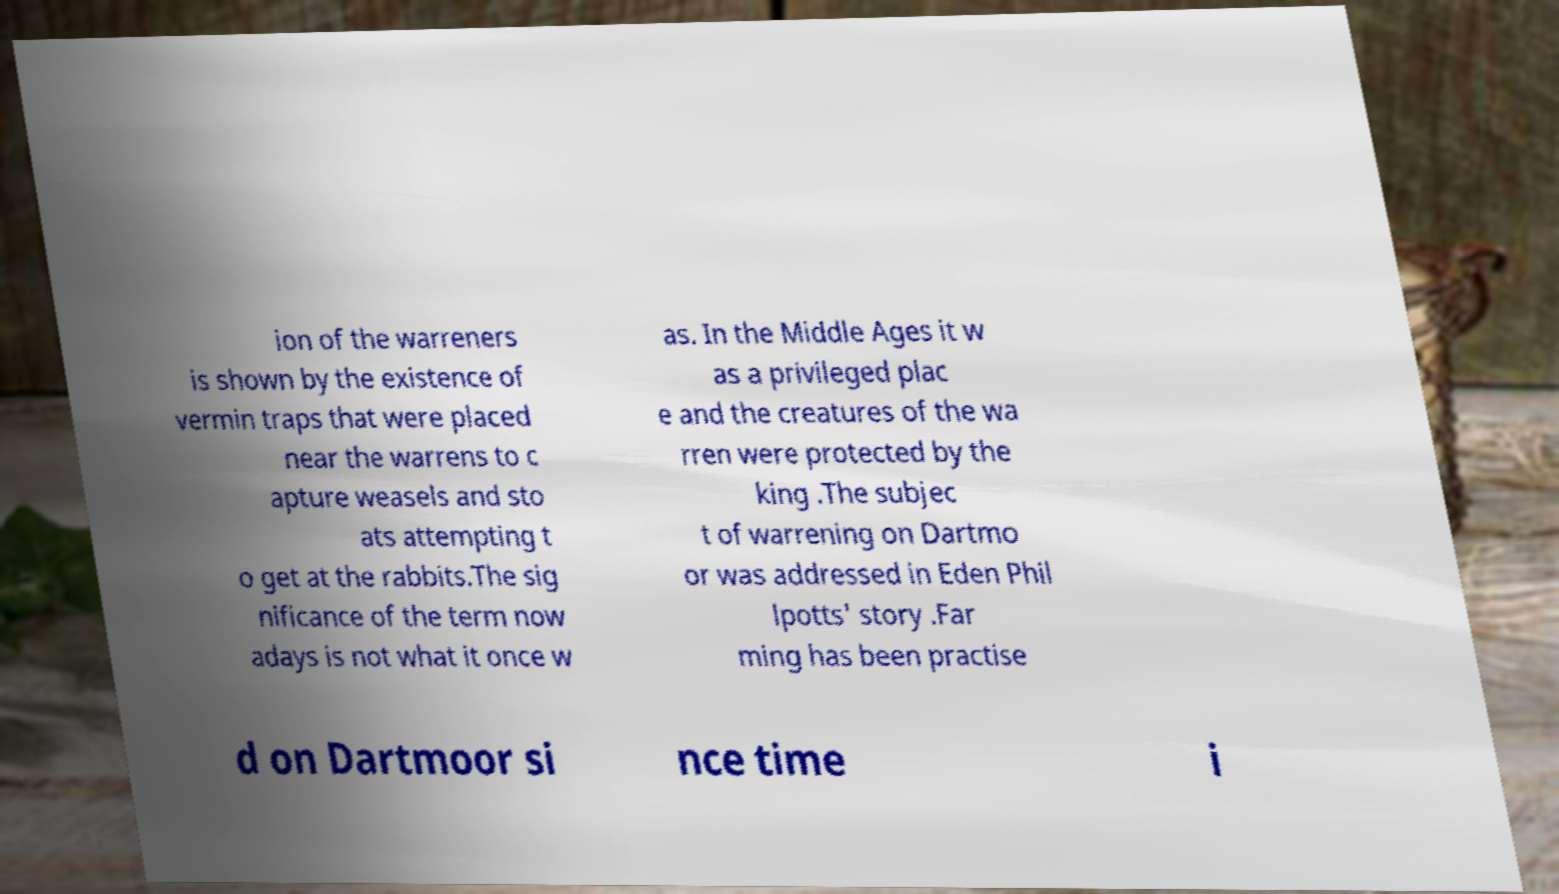Please identify and transcribe the text found in this image. ion of the warreners is shown by the existence of vermin traps that were placed near the warrens to c apture weasels and sto ats attempting t o get at the rabbits.The sig nificance of the term now adays is not what it once w as. In the Middle Ages it w as a privileged plac e and the creatures of the wa rren were protected by the king .The subjec t of warrening on Dartmo or was addressed in Eden Phil lpotts' story .Far ming has been practise d on Dartmoor si nce time i 